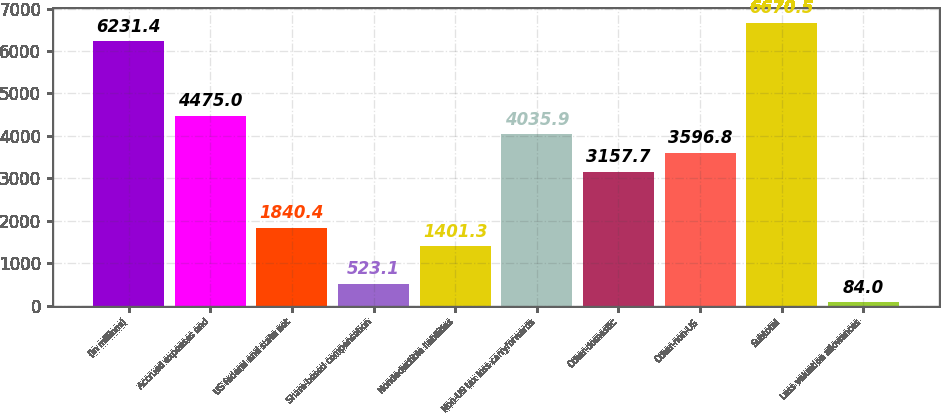<chart> <loc_0><loc_0><loc_500><loc_500><bar_chart><fcel>(in millions)<fcel>Accrued expenses and<fcel>US federal and state net<fcel>Share-based compensation<fcel>Nondeductible liabilities<fcel>Non-US tax loss carryforwards<fcel>Other-domestic<fcel>Other-non-US<fcel>Subtotal<fcel>Less valuation allowances<nl><fcel>6231.4<fcel>4475<fcel>1840.4<fcel>523.1<fcel>1401.3<fcel>4035.9<fcel>3157.7<fcel>3596.8<fcel>6670.5<fcel>84<nl></chart> 